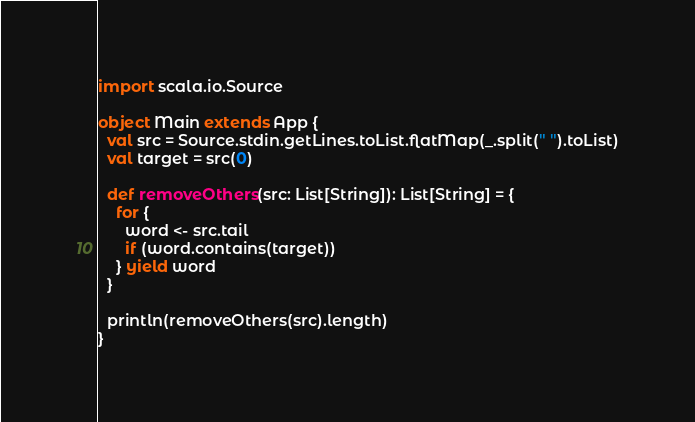<code> <loc_0><loc_0><loc_500><loc_500><_Scala_>import scala.io.Source

object Main extends App {
  val src = Source.stdin.getLines.toList.flatMap(_.split(" ").toList)
  val target = src(0)

  def removeOthers(src: List[String]): List[String] = {
    for {
      word <- src.tail
      if (word.contains(target))
    } yield word
  }

  println(removeOthers(src).length)
}</code> 